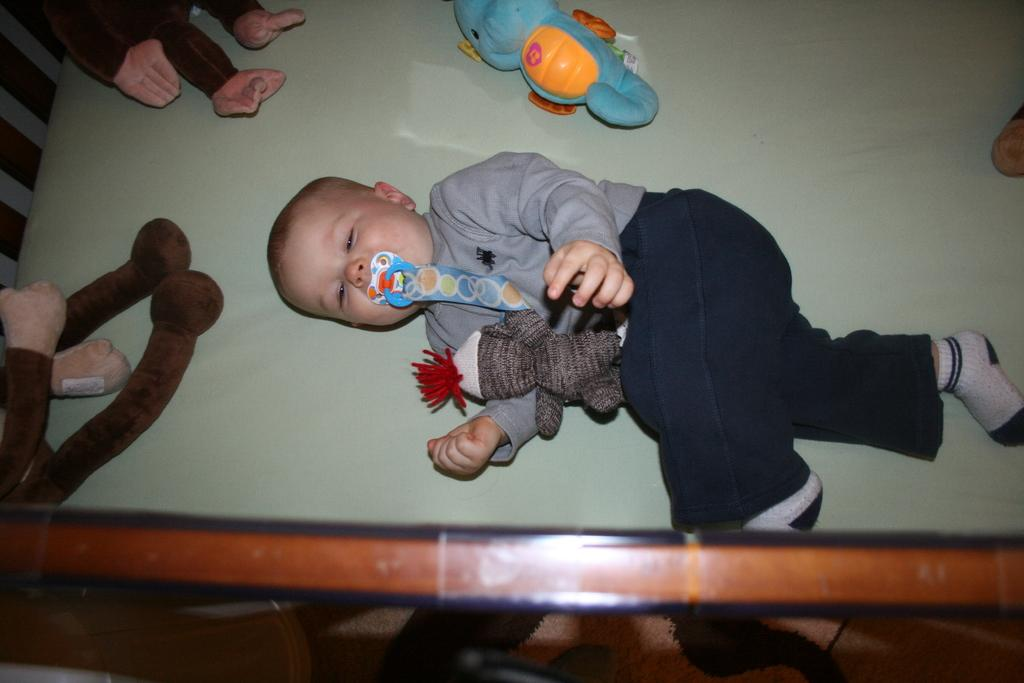What is the main subject of the image? There is a baby in the image. Where is the baby located? The baby is in a cradle. What can be seen around the baby? There are soft toys around the baby. What type of tin can be seen in the image? There is no tin present in the image. What instrument is the baby playing in the image? The image does not show the baby playing any instrument. 